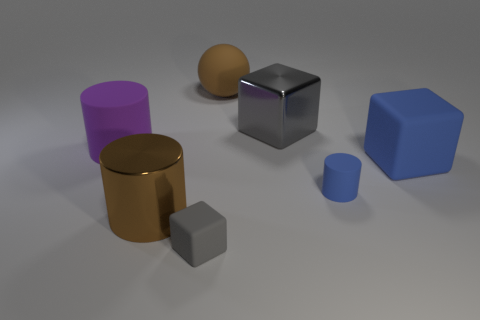Subtract all small cylinders. How many cylinders are left? 2 Add 1 gray shiny objects. How many objects exist? 8 Subtract 2 cylinders. How many cylinders are left? 1 Subtract all balls. How many objects are left? 6 Subtract all brown blocks. How many purple cylinders are left? 1 Subtract all brown cylinders. How many cylinders are left? 2 Subtract all cyan cylinders. Subtract all green cubes. How many cylinders are left? 3 Subtract all large cyan matte blocks. Subtract all big gray shiny things. How many objects are left? 6 Add 5 big matte objects. How many big matte objects are left? 8 Add 6 brown cylinders. How many brown cylinders exist? 7 